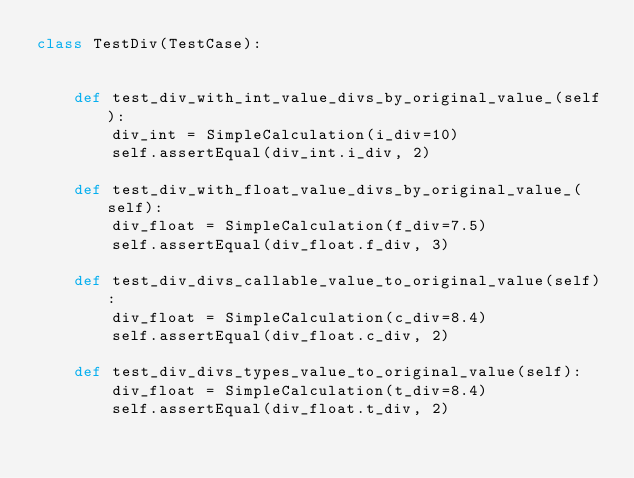Convert code to text. <code><loc_0><loc_0><loc_500><loc_500><_Python_>class TestDiv(TestCase):


    def test_div_with_int_value_divs_by_original_value_(self):
        div_int = SimpleCalculation(i_div=10)
        self.assertEqual(div_int.i_div, 2)

    def test_div_with_float_value_divs_by_original_value_(self):
        div_float = SimpleCalculation(f_div=7.5)
        self.assertEqual(div_float.f_div, 3)

    def test_div_divs_callable_value_to_original_value(self):
        div_float = SimpleCalculation(c_div=8.4)
        self.assertEqual(div_float.c_div, 2)

    def test_div_divs_types_value_to_original_value(self):
        div_float = SimpleCalculation(t_div=8.4)
        self.assertEqual(div_float.t_div, 2)
</code> 